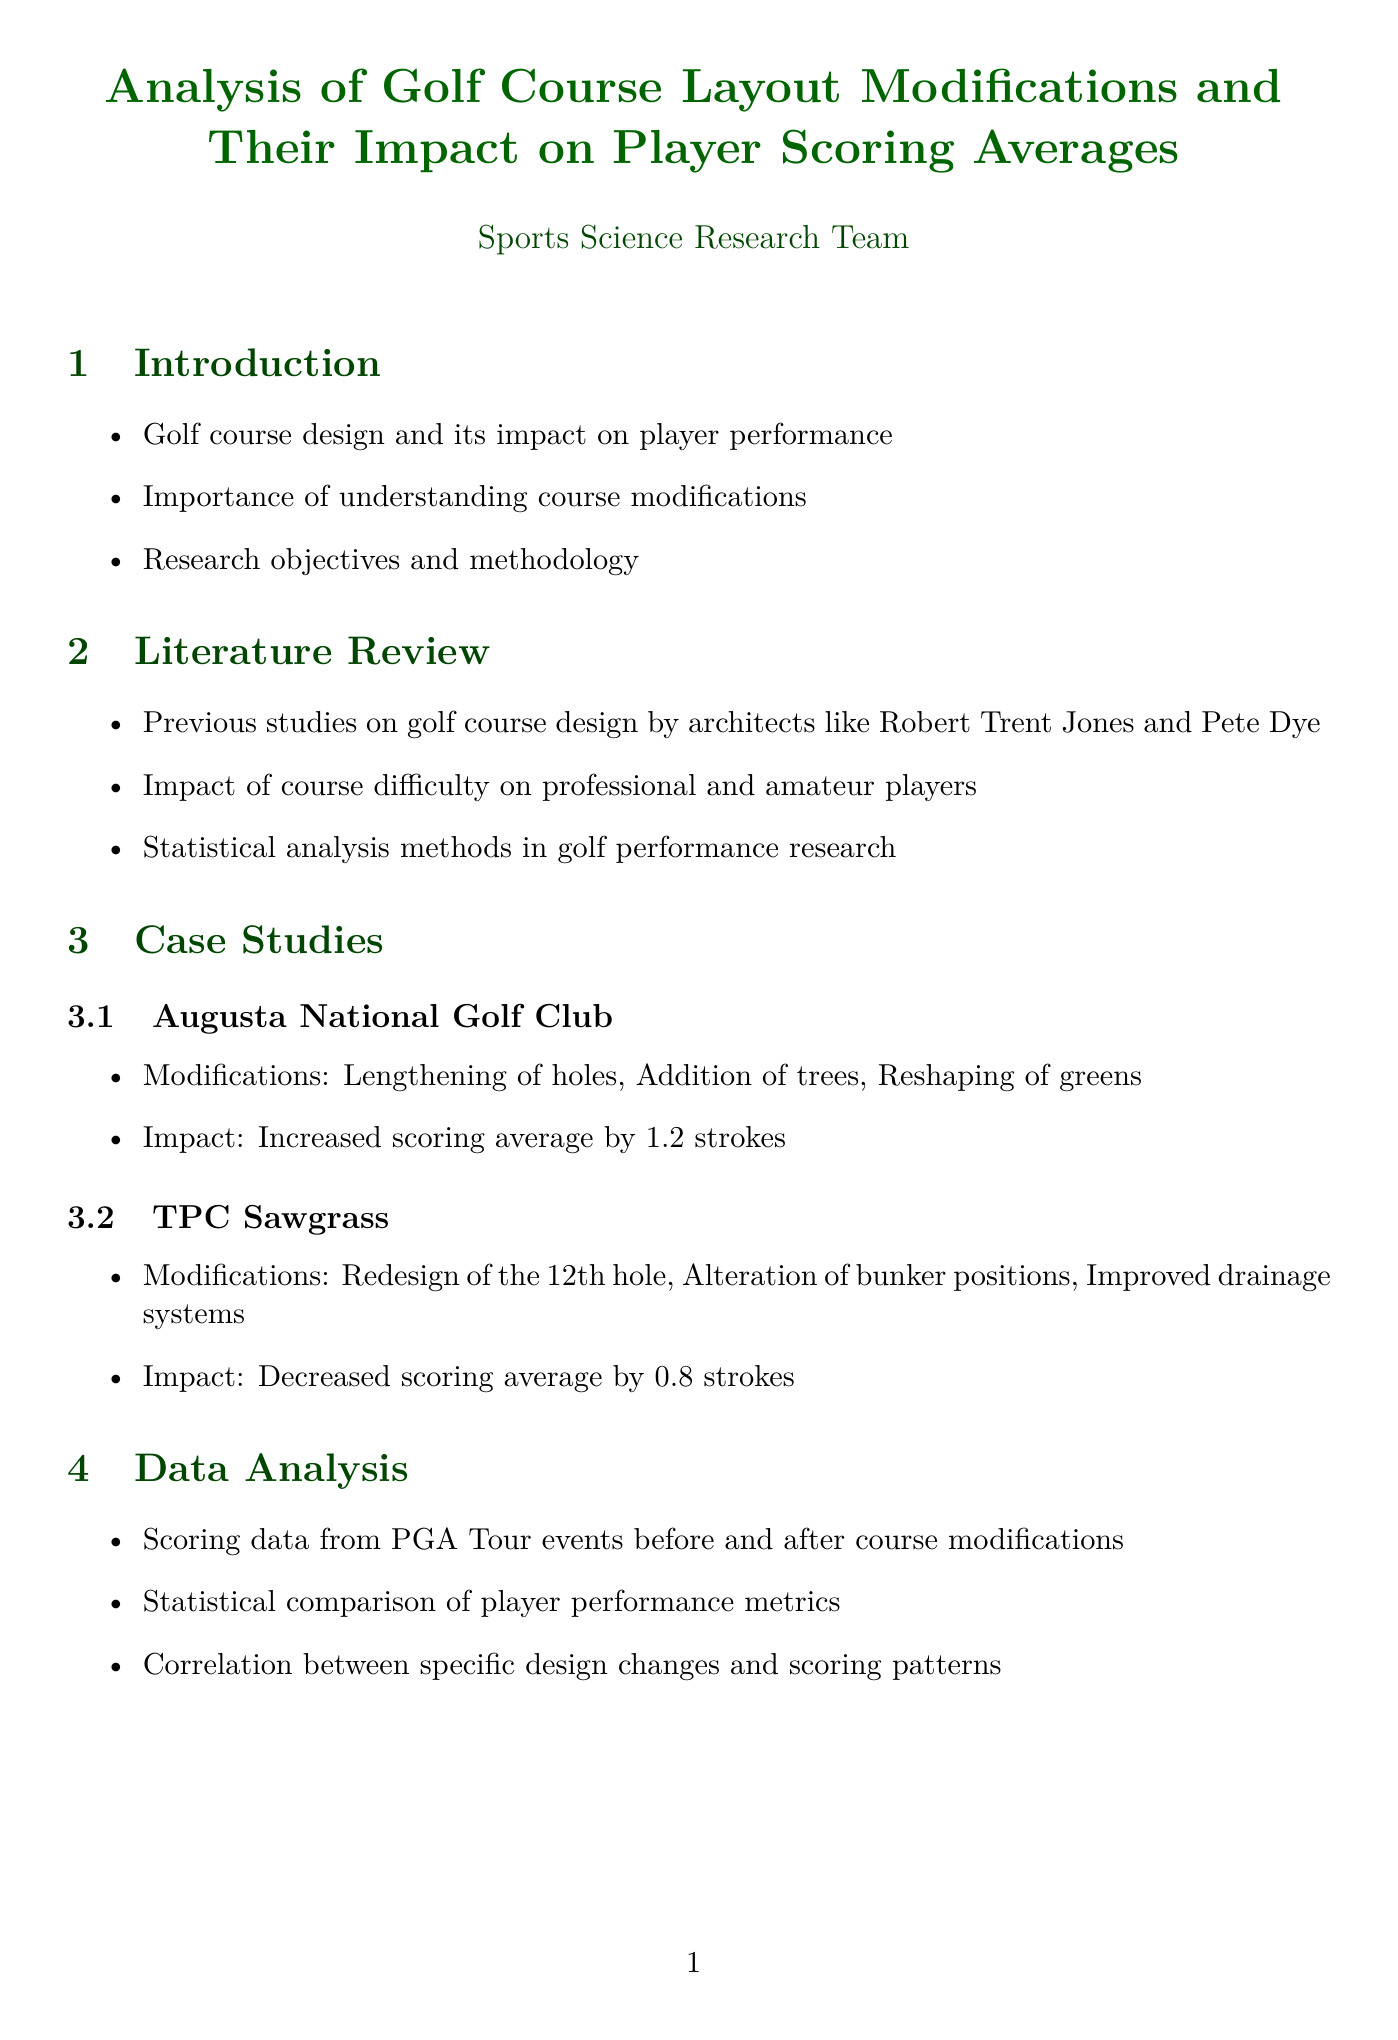What is the impact of modifying Augusta National Golf Club? The impact of modifications is an increased scoring average by 1.2 strokes.
Answer: Increased scoring average by 1.2 strokes What is the length increase of courses according to the report? The average increase in course length is 285 yards.
Answer: 285 yards Who is quoted regarding strategic decision-making in course modifications? Dr. Scott Lynn is quoted about the impact of course modifications emphasizing strategic decision-making.
Answer: Dr. Scott Lynn What statistical correlation is noted between green size and putts per round? The correlation value noted is -0.63.
Answer: -0.63 What are the implications for course designers mentioned in the report? The implications include balancing challenge and fairness in course modifications.
Answer: Balancing challenge and fairness What modification was done to TPC Sawgrass? One of the modifications was the redesign of the 12th hole.
Answer: Redesign of the 12th hole What is the change in scoring average after major renovations? The change in scoring average after renovations is +0.7 strokes.
Answer: +0.7 strokes What type of devices are used for precise course mapping? GPS and laser measuring devices are used for precise course mapping.
Answer: GPS and laser measuring devices Which journal is listed as relevant for golf science research? The International Journal of Golf Science is listed as a relevant journal.
Answer: International Journal of Golf Science 